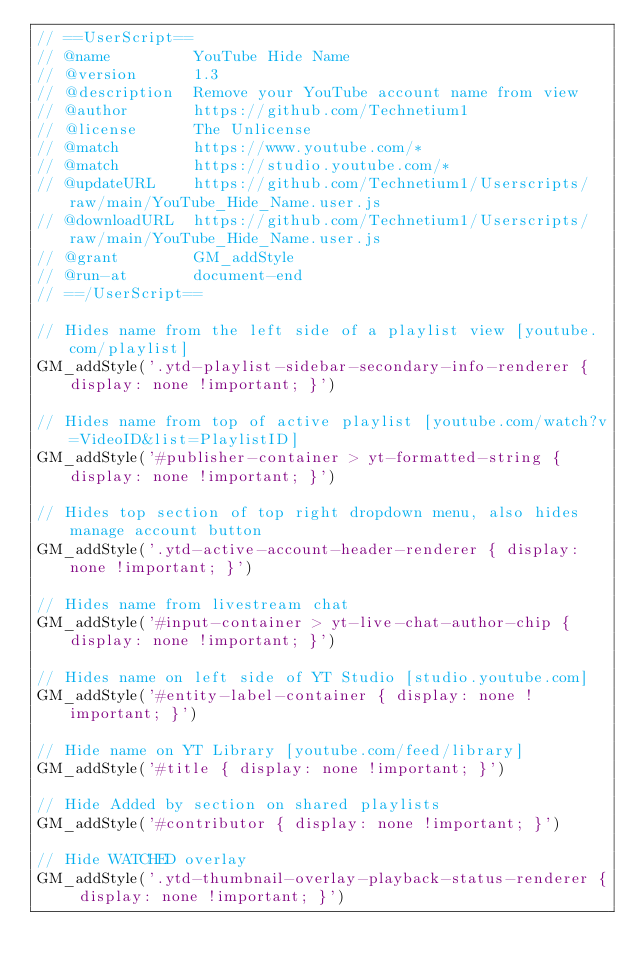Convert code to text. <code><loc_0><loc_0><loc_500><loc_500><_JavaScript_>// ==UserScript==
// @name         YouTube Hide Name
// @version      1.3
// @description  Remove your YouTube account name from view
// @author       https://github.com/Technetium1
// @license      The Unlicense
// @match        https://www.youtube.com/*
// @match        https://studio.youtube.com/*
// @updateURL    https://github.com/Technetium1/Userscripts/raw/main/YouTube_Hide_Name.user.js
// @downloadURL  https://github.com/Technetium1/Userscripts/raw/main/YouTube_Hide_Name.user.js
// @grant        GM_addStyle
// @run-at       document-end
// ==/UserScript==

// Hides name from the left side of a playlist view [youtube.com/playlist]
GM_addStyle('.ytd-playlist-sidebar-secondary-info-renderer { display: none !important; }')

// Hides name from top of active playlist [youtube.com/watch?v=VideoID&list=PlaylistID]
GM_addStyle('#publisher-container > yt-formatted-string { display: none !important; }')

// Hides top section of top right dropdown menu, also hides manage account button
GM_addStyle('.ytd-active-account-header-renderer { display: none !important; }')

// Hides name from livestream chat
GM_addStyle('#input-container > yt-live-chat-author-chip { display: none !important; }')

// Hides name on left side of YT Studio [studio.youtube.com]
GM_addStyle('#entity-label-container { display: none !important; }')

// Hide name on YT Library [youtube.com/feed/library]
GM_addStyle('#title { display: none !important; }')

// Hide Added by section on shared playlists
GM_addStyle('#contributor { display: none !important; }')

// Hide WATCHED overlay
GM_addStyle('.ytd-thumbnail-overlay-playback-status-renderer { display: none !important; }')
</code> 